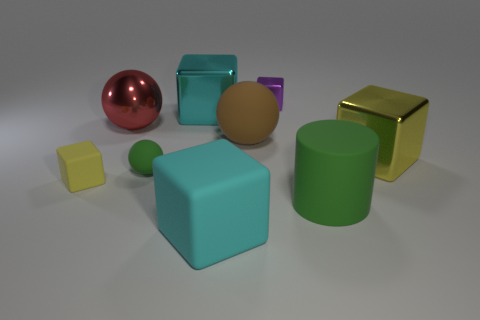Subtract all purple blocks. How many blocks are left? 4 Subtract all tiny purple cubes. How many cubes are left? 4 Add 1 green cylinders. How many objects exist? 10 Subtract all brown blocks. Subtract all brown cylinders. How many blocks are left? 5 Subtract all spheres. How many objects are left? 6 Add 9 large rubber balls. How many large rubber balls exist? 10 Subtract 1 cyan cubes. How many objects are left? 8 Subtract all large brown matte cubes. Subtract all metal spheres. How many objects are left? 8 Add 2 big red objects. How many big red objects are left? 3 